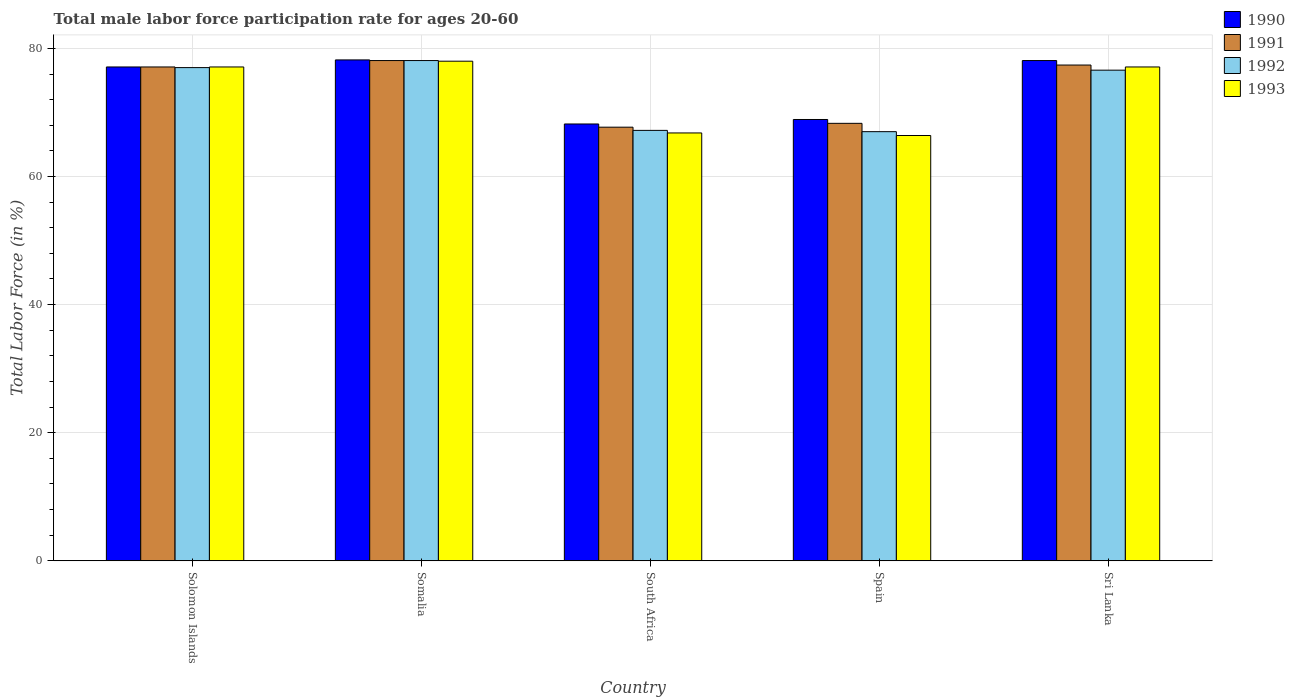How many groups of bars are there?
Make the answer very short. 5. Are the number of bars per tick equal to the number of legend labels?
Offer a terse response. Yes. Are the number of bars on each tick of the X-axis equal?
Give a very brief answer. Yes. How many bars are there on the 3rd tick from the right?
Your answer should be compact. 4. What is the label of the 3rd group of bars from the left?
Offer a very short reply. South Africa. In how many cases, is the number of bars for a given country not equal to the number of legend labels?
Your answer should be very brief. 0. What is the male labor force participation rate in 1991 in Somalia?
Provide a short and direct response. 78.1. Across all countries, what is the maximum male labor force participation rate in 1991?
Keep it short and to the point. 78.1. Across all countries, what is the minimum male labor force participation rate in 1993?
Your answer should be very brief. 66.4. In which country was the male labor force participation rate in 1990 maximum?
Keep it short and to the point. Somalia. In which country was the male labor force participation rate in 1991 minimum?
Your answer should be compact. South Africa. What is the total male labor force participation rate in 1991 in the graph?
Make the answer very short. 368.6. What is the difference between the male labor force participation rate in 1990 in South Africa and that in Spain?
Offer a terse response. -0.7. What is the difference between the male labor force participation rate in 1991 in Somalia and the male labor force participation rate in 1990 in Spain?
Provide a succinct answer. 9.2. What is the average male labor force participation rate in 1990 per country?
Give a very brief answer. 74.1. What is the difference between the male labor force participation rate of/in 1991 and male labor force participation rate of/in 1990 in South Africa?
Provide a short and direct response. -0.5. Is the male labor force participation rate in 1991 in Somalia less than that in Sri Lanka?
Give a very brief answer. No. What is the difference between the highest and the second highest male labor force participation rate in 1991?
Your answer should be very brief. -0.3. What is the difference between the highest and the lowest male labor force participation rate in 1991?
Provide a succinct answer. 10.4. In how many countries, is the male labor force participation rate in 1992 greater than the average male labor force participation rate in 1992 taken over all countries?
Your answer should be very brief. 3. Is the sum of the male labor force participation rate in 1990 in South Africa and Spain greater than the maximum male labor force participation rate in 1993 across all countries?
Provide a succinct answer. Yes. Is it the case that in every country, the sum of the male labor force participation rate in 1991 and male labor force participation rate in 1993 is greater than the sum of male labor force participation rate in 1992 and male labor force participation rate in 1990?
Provide a short and direct response. No. What does the 4th bar from the right in Somalia represents?
Keep it short and to the point. 1990. How many bars are there?
Your answer should be very brief. 20. How many countries are there in the graph?
Your response must be concise. 5. Does the graph contain any zero values?
Offer a terse response. No. What is the title of the graph?
Ensure brevity in your answer.  Total male labor force participation rate for ages 20-60. What is the label or title of the X-axis?
Provide a short and direct response. Country. What is the Total Labor Force (in %) in 1990 in Solomon Islands?
Ensure brevity in your answer.  77.1. What is the Total Labor Force (in %) in 1991 in Solomon Islands?
Offer a terse response. 77.1. What is the Total Labor Force (in %) of 1993 in Solomon Islands?
Offer a very short reply. 77.1. What is the Total Labor Force (in %) in 1990 in Somalia?
Offer a very short reply. 78.2. What is the Total Labor Force (in %) of 1991 in Somalia?
Your answer should be very brief. 78.1. What is the Total Labor Force (in %) in 1992 in Somalia?
Make the answer very short. 78.1. What is the Total Labor Force (in %) in 1990 in South Africa?
Provide a short and direct response. 68.2. What is the Total Labor Force (in %) of 1991 in South Africa?
Make the answer very short. 67.7. What is the Total Labor Force (in %) of 1992 in South Africa?
Give a very brief answer. 67.2. What is the Total Labor Force (in %) in 1993 in South Africa?
Offer a very short reply. 66.8. What is the Total Labor Force (in %) of 1990 in Spain?
Provide a succinct answer. 68.9. What is the Total Labor Force (in %) in 1991 in Spain?
Give a very brief answer. 68.3. What is the Total Labor Force (in %) of 1993 in Spain?
Provide a succinct answer. 66.4. What is the Total Labor Force (in %) in 1990 in Sri Lanka?
Ensure brevity in your answer.  78.1. What is the Total Labor Force (in %) of 1991 in Sri Lanka?
Ensure brevity in your answer.  77.4. What is the Total Labor Force (in %) of 1992 in Sri Lanka?
Ensure brevity in your answer.  76.6. What is the Total Labor Force (in %) of 1993 in Sri Lanka?
Provide a succinct answer. 77.1. Across all countries, what is the maximum Total Labor Force (in %) in 1990?
Your answer should be very brief. 78.2. Across all countries, what is the maximum Total Labor Force (in %) in 1991?
Your response must be concise. 78.1. Across all countries, what is the maximum Total Labor Force (in %) in 1992?
Ensure brevity in your answer.  78.1. Across all countries, what is the minimum Total Labor Force (in %) in 1990?
Make the answer very short. 68.2. Across all countries, what is the minimum Total Labor Force (in %) of 1991?
Keep it short and to the point. 67.7. Across all countries, what is the minimum Total Labor Force (in %) in 1992?
Provide a short and direct response. 67. Across all countries, what is the minimum Total Labor Force (in %) in 1993?
Keep it short and to the point. 66.4. What is the total Total Labor Force (in %) of 1990 in the graph?
Offer a very short reply. 370.5. What is the total Total Labor Force (in %) of 1991 in the graph?
Your answer should be very brief. 368.6. What is the total Total Labor Force (in %) of 1992 in the graph?
Provide a short and direct response. 365.9. What is the total Total Labor Force (in %) of 1993 in the graph?
Offer a very short reply. 365.4. What is the difference between the Total Labor Force (in %) of 1991 in Solomon Islands and that in Somalia?
Make the answer very short. -1. What is the difference between the Total Labor Force (in %) of 1992 in Solomon Islands and that in Somalia?
Keep it short and to the point. -1.1. What is the difference between the Total Labor Force (in %) in 1993 in Solomon Islands and that in Somalia?
Offer a very short reply. -0.9. What is the difference between the Total Labor Force (in %) of 1990 in Solomon Islands and that in South Africa?
Offer a very short reply. 8.9. What is the difference between the Total Labor Force (in %) of 1991 in Solomon Islands and that in South Africa?
Ensure brevity in your answer.  9.4. What is the difference between the Total Labor Force (in %) in 1991 in Solomon Islands and that in Spain?
Provide a succinct answer. 8.8. What is the difference between the Total Labor Force (in %) of 1992 in Solomon Islands and that in Spain?
Provide a short and direct response. 10. What is the difference between the Total Labor Force (in %) of 1990 in Solomon Islands and that in Sri Lanka?
Offer a very short reply. -1. What is the difference between the Total Labor Force (in %) of 1991 in Solomon Islands and that in Sri Lanka?
Ensure brevity in your answer.  -0.3. What is the difference between the Total Labor Force (in %) in 1993 in Solomon Islands and that in Sri Lanka?
Keep it short and to the point. 0. What is the difference between the Total Labor Force (in %) in 1990 in Somalia and that in South Africa?
Offer a very short reply. 10. What is the difference between the Total Labor Force (in %) of 1991 in Somalia and that in South Africa?
Your response must be concise. 10.4. What is the difference between the Total Labor Force (in %) of 1991 in Somalia and that in Spain?
Keep it short and to the point. 9.8. What is the difference between the Total Labor Force (in %) of 1992 in Somalia and that in Spain?
Your response must be concise. 11.1. What is the difference between the Total Labor Force (in %) of 1993 in Somalia and that in Spain?
Offer a very short reply. 11.6. What is the difference between the Total Labor Force (in %) in 1991 in Somalia and that in Sri Lanka?
Ensure brevity in your answer.  0.7. What is the difference between the Total Labor Force (in %) of 1993 in Somalia and that in Sri Lanka?
Provide a short and direct response. 0.9. What is the difference between the Total Labor Force (in %) of 1990 in South Africa and that in Spain?
Provide a succinct answer. -0.7. What is the difference between the Total Labor Force (in %) in 1992 in South Africa and that in Spain?
Provide a succinct answer. 0.2. What is the difference between the Total Labor Force (in %) of 1991 in South Africa and that in Sri Lanka?
Make the answer very short. -9.7. What is the difference between the Total Labor Force (in %) of 1992 in South Africa and that in Sri Lanka?
Offer a very short reply. -9.4. What is the difference between the Total Labor Force (in %) of 1991 in Spain and that in Sri Lanka?
Keep it short and to the point. -9.1. What is the difference between the Total Labor Force (in %) in 1992 in Spain and that in Sri Lanka?
Your answer should be very brief. -9.6. What is the difference between the Total Labor Force (in %) in 1990 in Solomon Islands and the Total Labor Force (in %) in 1991 in Somalia?
Your response must be concise. -1. What is the difference between the Total Labor Force (in %) in 1990 in Solomon Islands and the Total Labor Force (in %) in 1993 in Somalia?
Provide a short and direct response. -0.9. What is the difference between the Total Labor Force (in %) in 1990 in Solomon Islands and the Total Labor Force (in %) in 1993 in South Africa?
Provide a short and direct response. 10.3. What is the difference between the Total Labor Force (in %) of 1991 in Solomon Islands and the Total Labor Force (in %) of 1992 in South Africa?
Make the answer very short. 9.9. What is the difference between the Total Labor Force (in %) in 1991 in Solomon Islands and the Total Labor Force (in %) in 1993 in South Africa?
Keep it short and to the point. 10.3. What is the difference between the Total Labor Force (in %) in 1990 in Solomon Islands and the Total Labor Force (in %) in 1993 in Spain?
Offer a terse response. 10.7. What is the difference between the Total Labor Force (in %) in 1991 in Solomon Islands and the Total Labor Force (in %) in 1993 in Spain?
Your answer should be compact. 10.7. What is the difference between the Total Labor Force (in %) in 1990 in Solomon Islands and the Total Labor Force (in %) in 1991 in Sri Lanka?
Offer a very short reply. -0.3. What is the difference between the Total Labor Force (in %) of 1991 in Solomon Islands and the Total Labor Force (in %) of 1992 in Sri Lanka?
Make the answer very short. 0.5. What is the difference between the Total Labor Force (in %) of 1991 in Solomon Islands and the Total Labor Force (in %) of 1993 in Sri Lanka?
Give a very brief answer. 0. What is the difference between the Total Labor Force (in %) of 1992 in Solomon Islands and the Total Labor Force (in %) of 1993 in Sri Lanka?
Make the answer very short. -0.1. What is the difference between the Total Labor Force (in %) in 1991 in Somalia and the Total Labor Force (in %) in 1992 in South Africa?
Your answer should be compact. 10.9. What is the difference between the Total Labor Force (in %) in 1991 in Somalia and the Total Labor Force (in %) in 1993 in South Africa?
Your answer should be very brief. 11.3. What is the difference between the Total Labor Force (in %) of 1990 in Somalia and the Total Labor Force (in %) of 1991 in Spain?
Your response must be concise. 9.9. What is the difference between the Total Labor Force (in %) of 1990 in Somalia and the Total Labor Force (in %) of 1992 in Spain?
Your response must be concise. 11.2. What is the difference between the Total Labor Force (in %) of 1991 in Somalia and the Total Labor Force (in %) of 1992 in Spain?
Give a very brief answer. 11.1. What is the difference between the Total Labor Force (in %) in 1991 in Somalia and the Total Labor Force (in %) in 1993 in Spain?
Offer a terse response. 11.7. What is the difference between the Total Labor Force (in %) in 1990 in Somalia and the Total Labor Force (in %) in 1992 in Sri Lanka?
Provide a succinct answer. 1.6. What is the difference between the Total Labor Force (in %) of 1991 in Somalia and the Total Labor Force (in %) of 1993 in Sri Lanka?
Ensure brevity in your answer.  1. What is the difference between the Total Labor Force (in %) of 1992 in Somalia and the Total Labor Force (in %) of 1993 in Sri Lanka?
Your response must be concise. 1. What is the difference between the Total Labor Force (in %) of 1990 in South Africa and the Total Labor Force (in %) of 1991 in Spain?
Give a very brief answer. -0.1. What is the difference between the Total Labor Force (in %) of 1990 in South Africa and the Total Labor Force (in %) of 1992 in Spain?
Offer a very short reply. 1.2. What is the difference between the Total Labor Force (in %) of 1992 in South Africa and the Total Labor Force (in %) of 1993 in Spain?
Give a very brief answer. 0.8. What is the difference between the Total Labor Force (in %) in 1990 in South Africa and the Total Labor Force (in %) in 1993 in Sri Lanka?
Your answer should be very brief. -8.9. What is the difference between the Total Labor Force (in %) in 1991 in South Africa and the Total Labor Force (in %) in 1992 in Sri Lanka?
Provide a succinct answer. -8.9. What is the difference between the Total Labor Force (in %) of 1991 in South Africa and the Total Labor Force (in %) of 1993 in Sri Lanka?
Offer a terse response. -9.4. What is the difference between the Total Labor Force (in %) in 1992 in South Africa and the Total Labor Force (in %) in 1993 in Sri Lanka?
Provide a succinct answer. -9.9. What is the difference between the Total Labor Force (in %) of 1990 in Spain and the Total Labor Force (in %) of 1993 in Sri Lanka?
Ensure brevity in your answer.  -8.2. What is the difference between the Total Labor Force (in %) in 1991 in Spain and the Total Labor Force (in %) in 1992 in Sri Lanka?
Your answer should be compact. -8.3. What is the difference between the Total Labor Force (in %) in 1991 in Spain and the Total Labor Force (in %) in 1993 in Sri Lanka?
Offer a very short reply. -8.8. What is the average Total Labor Force (in %) in 1990 per country?
Your answer should be compact. 74.1. What is the average Total Labor Force (in %) of 1991 per country?
Keep it short and to the point. 73.72. What is the average Total Labor Force (in %) of 1992 per country?
Provide a succinct answer. 73.18. What is the average Total Labor Force (in %) of 1993 per country?
Provide a short and direct response. 73.08. What is the difference between the Total Labor Force (in %) in 1990 and Total Labor Force (in %) in 1991 in Solomon Islands?
Provide a short and direct response. 0. What is the difference between the Total Labor Force (in %) in 1990 and Total Labor Force (in %) in 1993 in Solomon Islands?
Your response must be concise. 0. What is the difference between the Total Labor Force (in %) in 1991 and Total Labor Force (in %) in 1992 in Solomon Islands?
Offer a very short reply. 0.1. What is the difference between the Total Labor Force (in %) in 1991 and Total Labor Force (in %) in 1993 in Solomon Islands?
Give a very brief answer. 0. What is the difference between the Total Labor Force (in %) of 1991 and Total Labor Force (in %) of 1993 in Somalia?
Provide a short and direct response. 0.1. What is the difference between the Total Labor Force (in %) in 1990 and Total Labor Force (in %) in 1991 in Spain?
Give a very brief answer. 0.6. What is the difference between the Total Labor Force (in %) in 1991 and Total Labor Force (in %) in 1992 in Spain?
Ensure brevity in your answer.  1.3. What is the difference between the Total Labor Force (in %) in 1991 and Total Labor Force (in %) in 1993 in Spain?
Your answer should be compact. 1.9. What is the difference between the Total Labor Force (in %) in 1992 and Total Labor Force (in %) in 1993 in Spain?
Provide a short and direct response. 0.6. What is the difference between the Total Labor Force (in %) of 1990 and Total Labor Force (in %) of 1991 in Sri Lanka?
Ensure brevity in your answer.  0.7. What is the difference between the Total Labor Force (in %) in 1990 and Total Labor Force (in %) in 1992 in Sri Lanka?
Provide a succinct answer. 1.5. What is the difference between the Total Labor Force (in %) of 1991 and Total Labor Force (in %) of 1992 in Sri Lanka?
Your answer should be very brief. 0.8. What is the difference between the Total Labor Force (in %) of 1991 and Total Labor Force (in %) of 1993 in Sri Lanka?
Keep it short and to the point. 0.3. What is the ratio of the Total Labor Force (in %) of 1990 in Solomon Islands to that in Somalia?
Give a very brief answer. 0.99. What is the ratio of the Total Labor Force (in %) in 1991 in Solomon Islands to that in Somalia?
Keep it short and to the point. 0.99. What is the ratio of the Total Labor Force (in %) in 1992 in Solomon Islands to that in Somalia?
Give a very brief answer. 0.99. What is the ratio of the Total Labor Force (in %) of 1993 in Solomon Islands to that in Somalia?
Give a very brief answer. 0.99. What is the ratio of the Total Labor Force (in %) in 1990 in Solomon Islands to that in South Africa?
Make the answer very short. 1.13. What is the ratio of the Total Labor Force (in %) in 1991 in Solomon Islands to that in South Africa?
Offer a very short reply. 1.14. What is the ratio of the Total Labor Force (in %) in 1992 in Solomon Islands to that in South Africa?
Keep it short and to the point. 1.15. What is the ratio of the Total Labor Force (in %) in 1993 in Solomon Islands to that in South Africa?
Make the answer very short. 1.15. What is the ratio of the Total Labor Force (in %) in 1990 in Solomon Islands to that in Spain?
Give a very brief answer. 1.12. What is the ratio of the Total Labor Force (in %) of 1991 in Solomon Islands to that in Spain?
Ensure brevity in your answer.  1.13. What is the ratio of the Total Labor Force (in %) of 1992 in Solomon Islands to that in Spain?
Offer a terse response. 1.15. What is the ratio of the Total Labor Force (in %) in 1993 in Solomon Islands to that in Spain?
Provide a succinct answer. 1.16. What is the ratio of the Total Labor Force (in %) in 1990 in Solomon Islands to that in Sri Lanka?
Ensure brevity in your answer.  0.99. What is the ratio of the Total Labor Force (in %) of 1991 in Solomon Islands to that in Sri Lanka?
Make the answer very short. 1. What is the ratio of the Total Labor Force (in %) of 1992 in Solomon Islands to that in Sri Lanka?
Make the answer very short. 1.01. What is the ratio of the Total Labor Force (in %) in 1993 in Solomon Islands to that in Sri Lanka?
Provide a succinct answer. 1. What is the ratio of the Total Labor Force (in %) of 1990 in Somalia to that in South Africa?
Your response must be concise. 1.15. What is the ratio of the Total Labor Force (in %) of 1991 in Somalia to that in South Africa?
Your response must be concise. 1.15. What is the ratio of the Total Labor Force (in %) of 1992 in Somalia to that in South Africa?
Ensure brevity in your answer.  1.16. What is the ratio of the Total Labor Force (in %) in 1993 in Somalia to that in South Africa?
Your response must be concise. 1.17. What is the ratio of the Total Labor Force (in %) in 1990 in Somalia to that in Spain?
Give a very brief answer. 1.14. What is the ratio of the Total Labor Force (in %) in 1991 in Somalia to that in Spain?
Keep it short and to the point. 1.14. What is the ratio of the Total Labor Force (in %) of 1992 in Somalia to that in Spain?
Offer a terse response. 1.17. What is the ratio of the Total Labor Force (in %) of 1993 in Somalia to that in Spain?
Your answer should be very brief. 1.17. What is the ratio of the Total Labor Force (in %) of 1990 in Somalia to that in Sri Lanka?
Keep it short and to the point. 1. What is the ratio of the Total Labor Force (in %) of 1992 in Somalia to that in Sri Lanka?
Ensure brevity in your answer.  1.02. What is the ratio of the Total Labor Force (in %) of 1993 in Somalia to that in Sri Lanka?
Your response must be concise. 1.01. What is the ratio of the Total Labor Force (in %) in 1990 in South Africa to that in Spain?
Ensure brevity in your answer.  0.99. What is the ratio of the Total Labor Force (in %) of 1991 in South Africa to that in Spain?
Provide a succinct answer. 0.99. What is the ratio of the Total Labor Force (in %) of 1992 in South Africa to that in Spain?
Ensure brevity in your answer.  1. What is the ratio of the Total Labor Force (in %) of 1993 in South Africa to that in Spain?
Give a very brief answer. 1.01. What is the ratio of the Total Labor Force (in %) in 1990 in South Africa to that in Sri Lanka?
Offer a very short reply. 0.87. What is the ratio of the Total Labor Force (in %) of 1991 in South Africa to that in Sri Lanka?
Your response must be concise. 0.87. What is the ratio of the Total Labor Force (in %) in 1992 in South Africa to that in Sri Lanka?
Make the answer very short. 0.88. What is the ratio of the Total Labor Force (in %) of 1993 in South Africa to that in Sri Lanka?
Give a very brief answer. 0.87. What is the ratio of the Total Labor Force (in %) of 1990 in Spain to that in Sri Lanka?
Provide a succinct answer. 0.88. What is the ratio of the Total Labor Force (in %) of 1991 in Spain to that in Sri Lanka?
Your answer should be compact. 0.88. What is the ratio of the Total Labor Force (in %) in 1992 in Spain to that in Sri Lanka?
Your answer should be very brief. 0.87. What is the ratio of the Total Labor Force (in %) of 1993 in Spain to that in Sri Lanka?
Provide a succinct answer. 0.86. What is the difference between the highest and the second highest Total Labor Force (in %) in 1990?
Ensure brevity in your answer.  0.1. What is the difference between the highest and the second highest Total Labor Force (in %) in 1991?
Provide a succinct answer. 0.7. What is the difference between the highest and the second highest Total Labor Force (in %) in 1993?
Ensure brevity in your answer.  0.9. What is the difference between the highest and the lowest Total Labor Force (in %) in 1990?
Give a very brief answer. 10. What is the difference between the highest and the lowest Total Labor Force (in %) in 1993?
Your answer should be very brief. 11.6. 